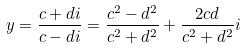<formula> <loc_0><loc_0><loc_500><loc_500>y = { \frac { c + d i } { c - d i } } = { \frac { c ^ { 2 } - d ^ { 2 } } { c ^ { 2 } + d ^ { 2 } } } + { \frac { 2 c d } { c ^ { 2 } + d ^ { 2 } } } i</formula> 